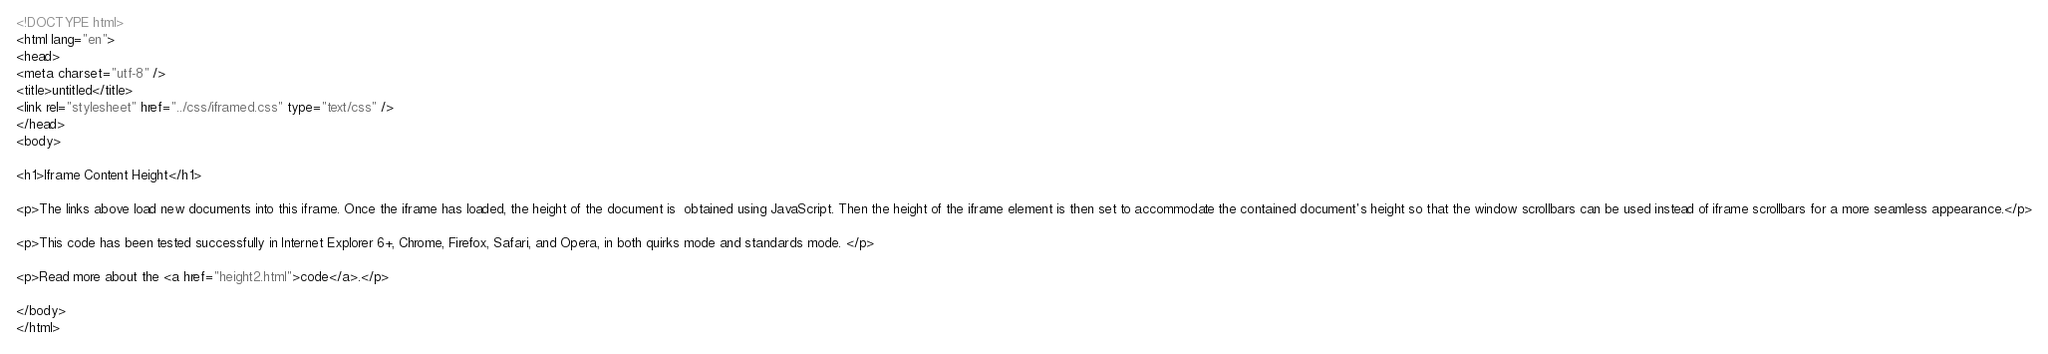<code> <loc_0><loc_0><loc_500><loc_500><_HTML_><!DOCTYPE html>
<html lang="en">
<head>
<meta charset="utf-8" />
<title>untitled</title>
<link rel="stylesheet" href="../css/iframed.css" type="text/css" />
</head>
<body>

<h1>Iframe Content Height</h1>

<p>The links above load new documents into this iframe. Once the iframe has loaded, the height of the document is  obtained using JavaScript. Then the height of the iframe element is then set to accommodate the contained document's height so that the window scrollbars can be used instead of iframe scrollbars for a more seamless appearance.</p>

<p>This code has been tested successfully in Internet Explorer 6+, Chrome, Firefox, Safari, and Opera, in both quirks mode and standards mode. </p>

<p>Read more about the <a href="height2.html">code</a>.</p>

</body>
</html>
</code> 